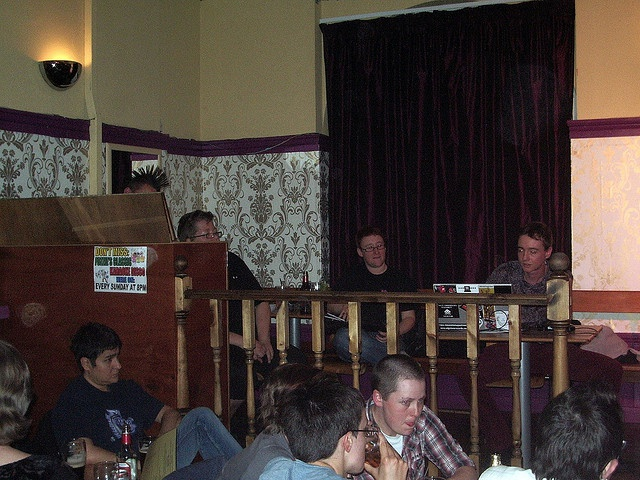Describe the objects in this image and their specific colors. I can see people in gray, black, navy, and darkblue tones, people in gray, black, darkgray, and tan tones, people in gray, black, and white tones, people in gray, black, and darkgray tones, and chair in gray, black, brown, and maroon tones in this image. 